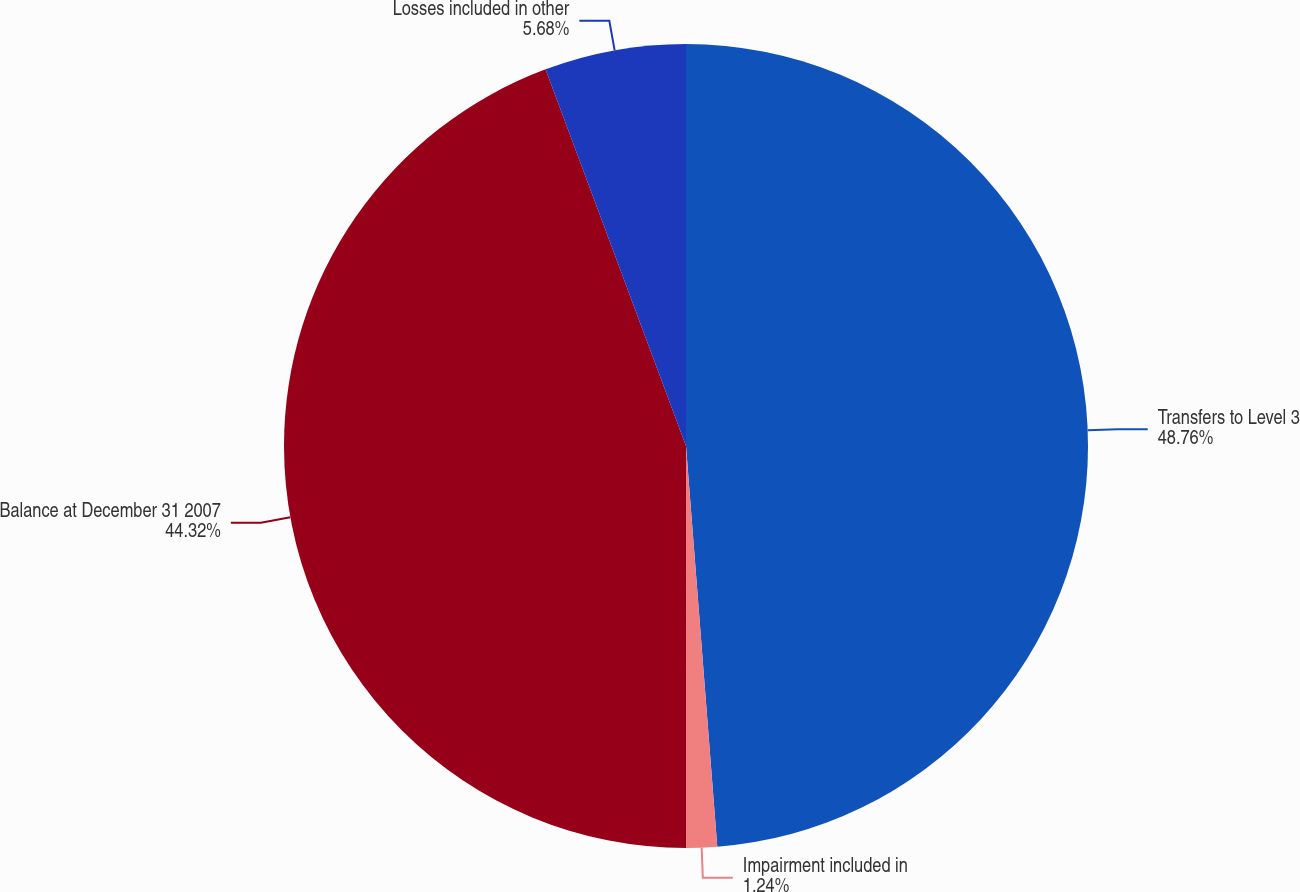<chart> <loc_0><loc_0><loc_500><loc_500><pie_chart><fcel>Transfers to Level 3<fcel>Impairment included in<fcel>Balance at December 31 2007<fcel>Losses included in other<nl><fcel>48.76%<fcel>1.24%<fcel>44.32%<fcel>5.68%<nl></chart> 